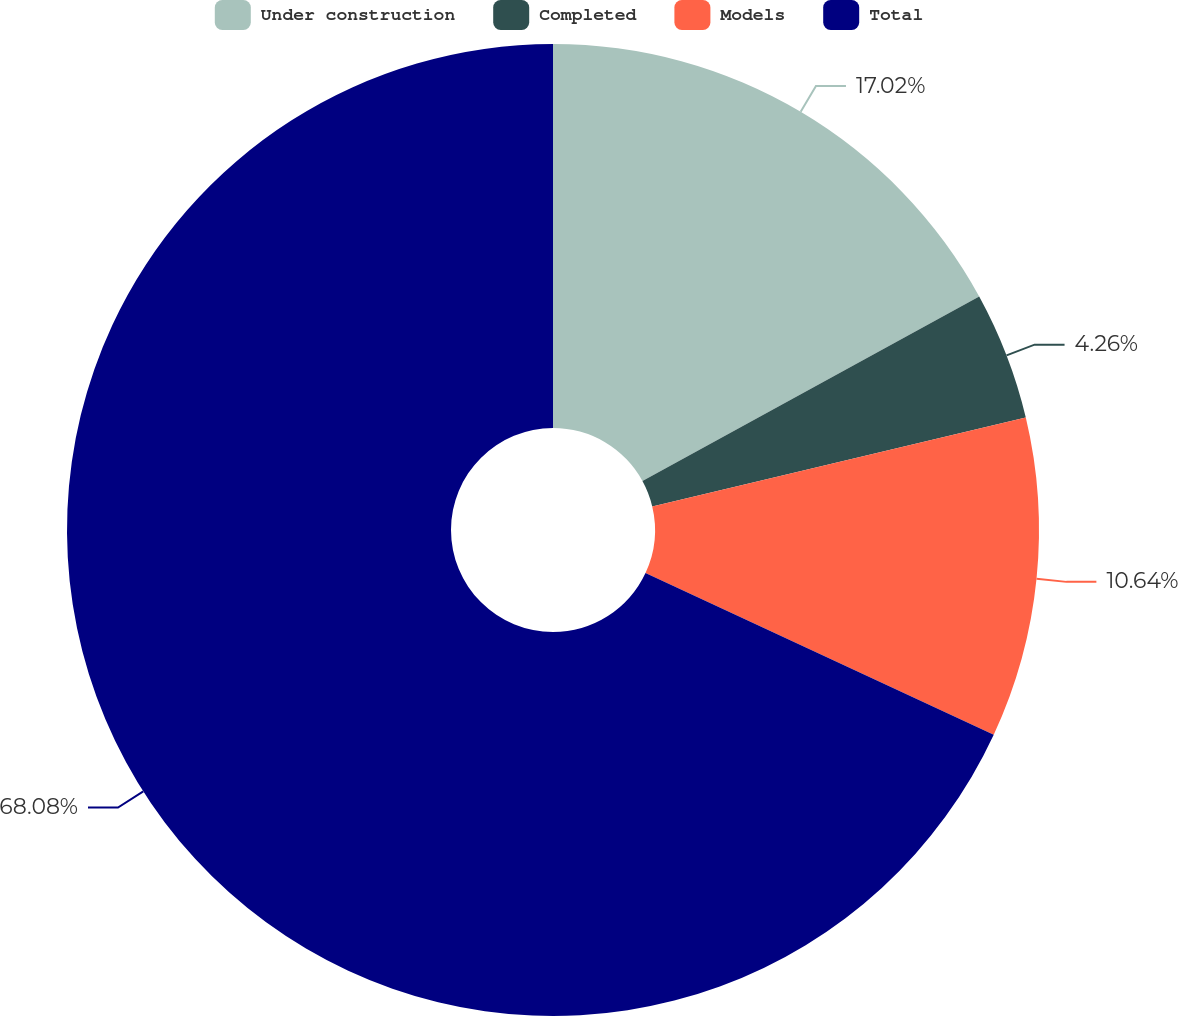Convert chart. <chart><loc_0><loc_0><loc_500><loc_500><pie_chart><fcel>Under construction<fcel>Completed<fcel>Models<fcel>Total<nl><fcel>17.02%<fcel>4.26%<fcel>10.64%<fcel>68.07%<nl></chart> 